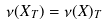<formula> <loc_0><loc_0><loc_500><loc_500>\nu ( X _ { T } ) = \nu ( X ) _ { T }</formula> 